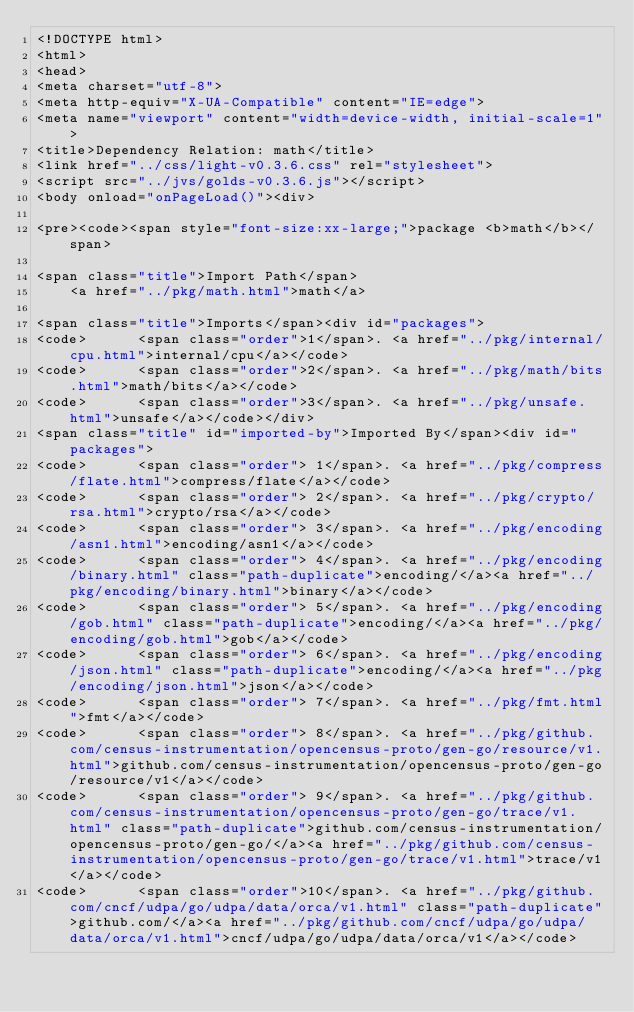<code> <loc_0><loc_0><loc_500><loc_500><_HTML_><!DOCTYPE html>
<html>
<head>
<meta charset="utf-8">
<meta http-equiv="X-UA-Compatible" content="IE=edge">
<meta name="viewport" content="width=device-width, initial-scale=1">
<title>Dependency Relation: math</title>
<link href="../css/light-v0.3.6.css" rel="stylesheet">
<script src="../jvs/golds-v0.3.6.js"></script>
<body onload="onPageLoad()"><div>

<pre><code><span style="font-size:xx-large;">package <b>math</b></span>

<span class="title">Import Path</span>
	<a href="../pkg/math.html">math</a>

<span class="title">Imports</span><div id="packages">
<code>      <span class="order">1</span>. <a href="../pkg/internal/cpu.html">internal/cpu</a></code>
<code>      <span class="order">2</span>. <a href="../pkg/math/bits.html">math/bits</a></code>
<code>      <span class="order">3</span>. <a href="../pkg/unsafe.html">unsafe</a></code></div>
<span class="title" id="imported-by">Imported By</span><div id="packages">
<code>      <span class="order"> 1</span>. <a href="../pkg/compress/flate.html">compress/flate</a></code>
<code>      <span class="order"> 2</span>. <a href="../pkg/crypto/rsa.html">crypto/rsa</a></code>
<code>      <span class="order"> 3</span>. <a href="../pkg/encoding/asn1.html">encoding/asn1</a></code>
<code>      <span class="order"> 4</span>. <a href="../pkg/encoding/binary.html" class="path-duplicate">encoding/</a><a href="../pkg/encoding/binary.html">binary</a></code>
<code>      <span class="order"> 5</span>. <a href="../pkg/encoding/gob.html" class="path-duplicate">encoding/</a><a href="../pkg/encoding/gob.html">gob</a></code>
<code>      <span class="order"> 6</span>. <a href="../pkg/encoding/json.html" class="path-duplicate">encoding/</a><a href="../pkg/encoding/json.html">json</a></code>
<code>      <span class="order"> 7</span>. <a href="../pkg/fmt.html">fmt</a></code>
<code>      <span class="order"> 8</span>. <a href="../pkg/github.com/census-instrumentation/opencensus-proto/gen-go/resource/v1.html">github.com/census-instrumentation/opencensus-proto/gen-go/resource/v1</a></code>
<code>      <span class="order"> 9</span>. <a href="../pkg/github.com/census-instrumentation/opencensus-proto/gen-go/trace/v1.html" class="path-duplicate">github.com/census-instrumentation/opencensus-proto/gen-go/</a><a href="../pkg/github.com/census-instrumentation/opencensus-proto/gen-go/trace/v1.html">trace/v1</a></code>
<code>      <span class="order">10</span>. <a href="../pkg/github.com/cncf/udpa/go/udpa/data/orca/v1.html" class="path-duplicate">github.com/</a><a href="../pkg/github.com/cncf/udpa/go/udpa/data/orca/v1.html">cncf/udpa/go/udpa/data/orca/v1</a></code></code> 